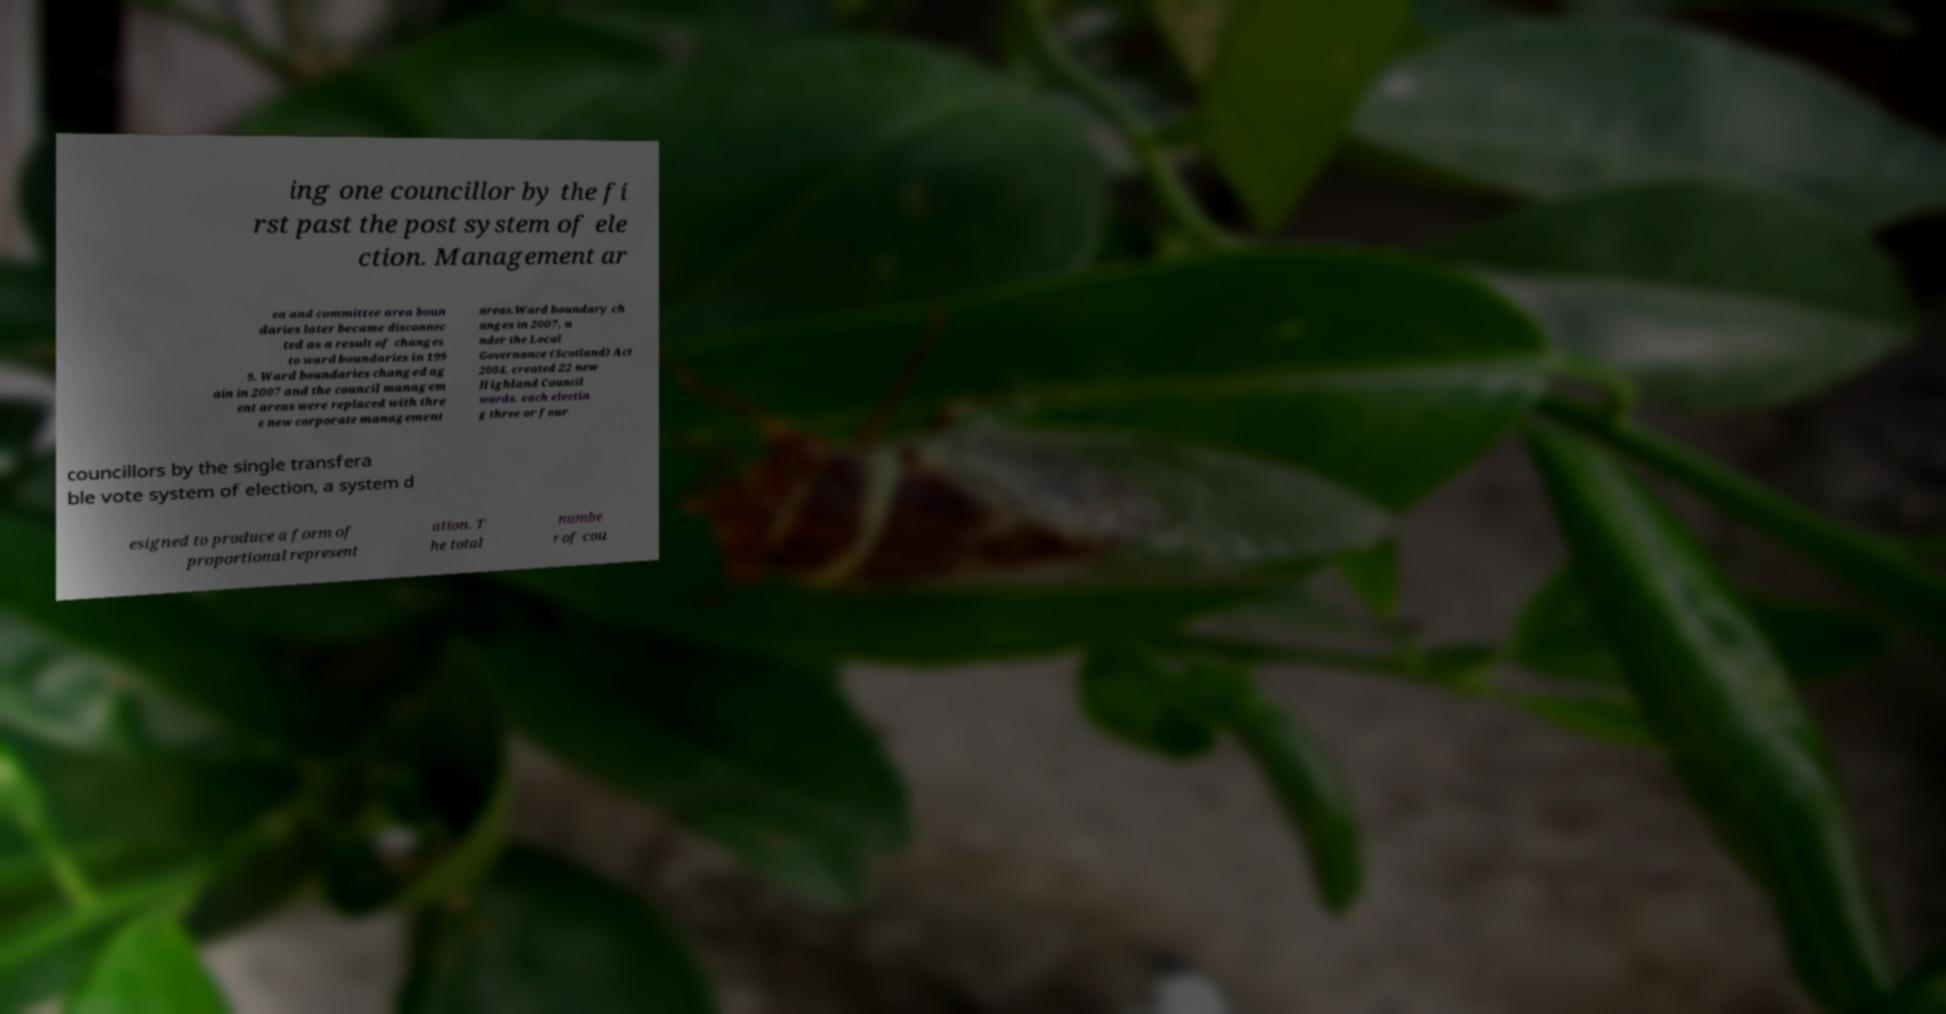For documentation purposes, I need the text within this image transcribed. Could you provide that? ing one councillor by the fi rst past the post system of ele ction. Management ar ea and committee area boun daries later became disconnec ted as a result of changes to ward boundaries in 199 9. Ward boundaries changed ag ain in 2007 and the council managem ent areas were replaced with thre e new corporate management areas.Ward boundary ch anges in 2007, u nder the Local Governance (Scotland) Act 2004, created 22 new Highland Council wards, each electin g three or four councillors by the single transfera ble vote system of election, a system d esigned to produce a form of proportional represent ation. T he total numbe r of cou 